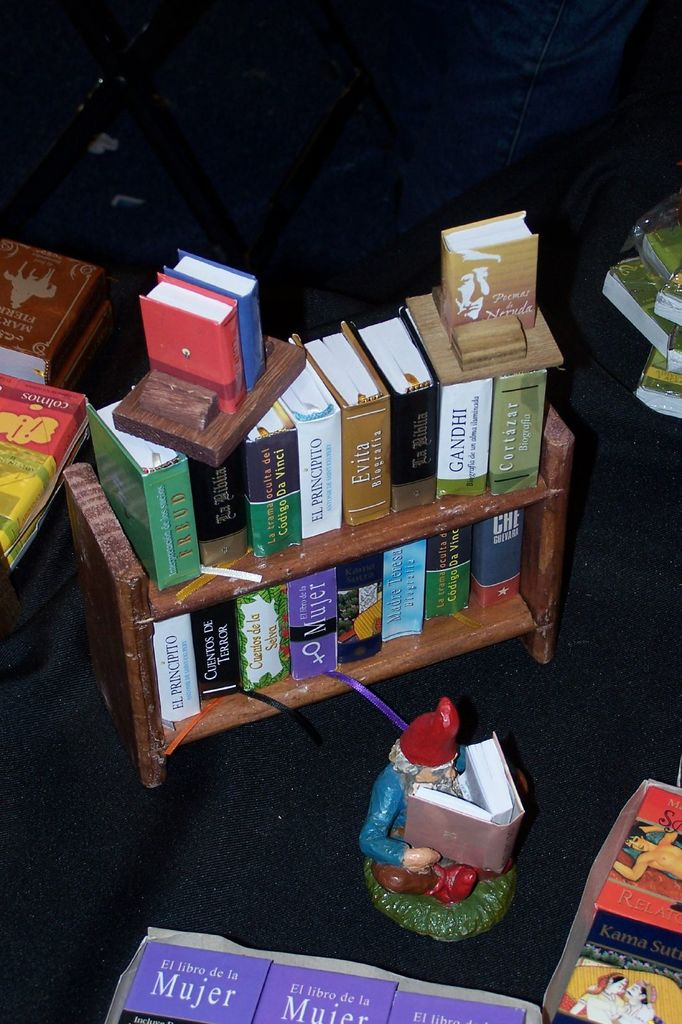Explore the role of the gnome figure in this miniature display. The gnome figure, depicted as reading, serves as a charming and imaginative focal point that personifies the joy of reading. It adds an element of fantasy and whimsy to the display, suggesting that literature can transport readers into fantastical realms and offer delightful escapades from reality. 